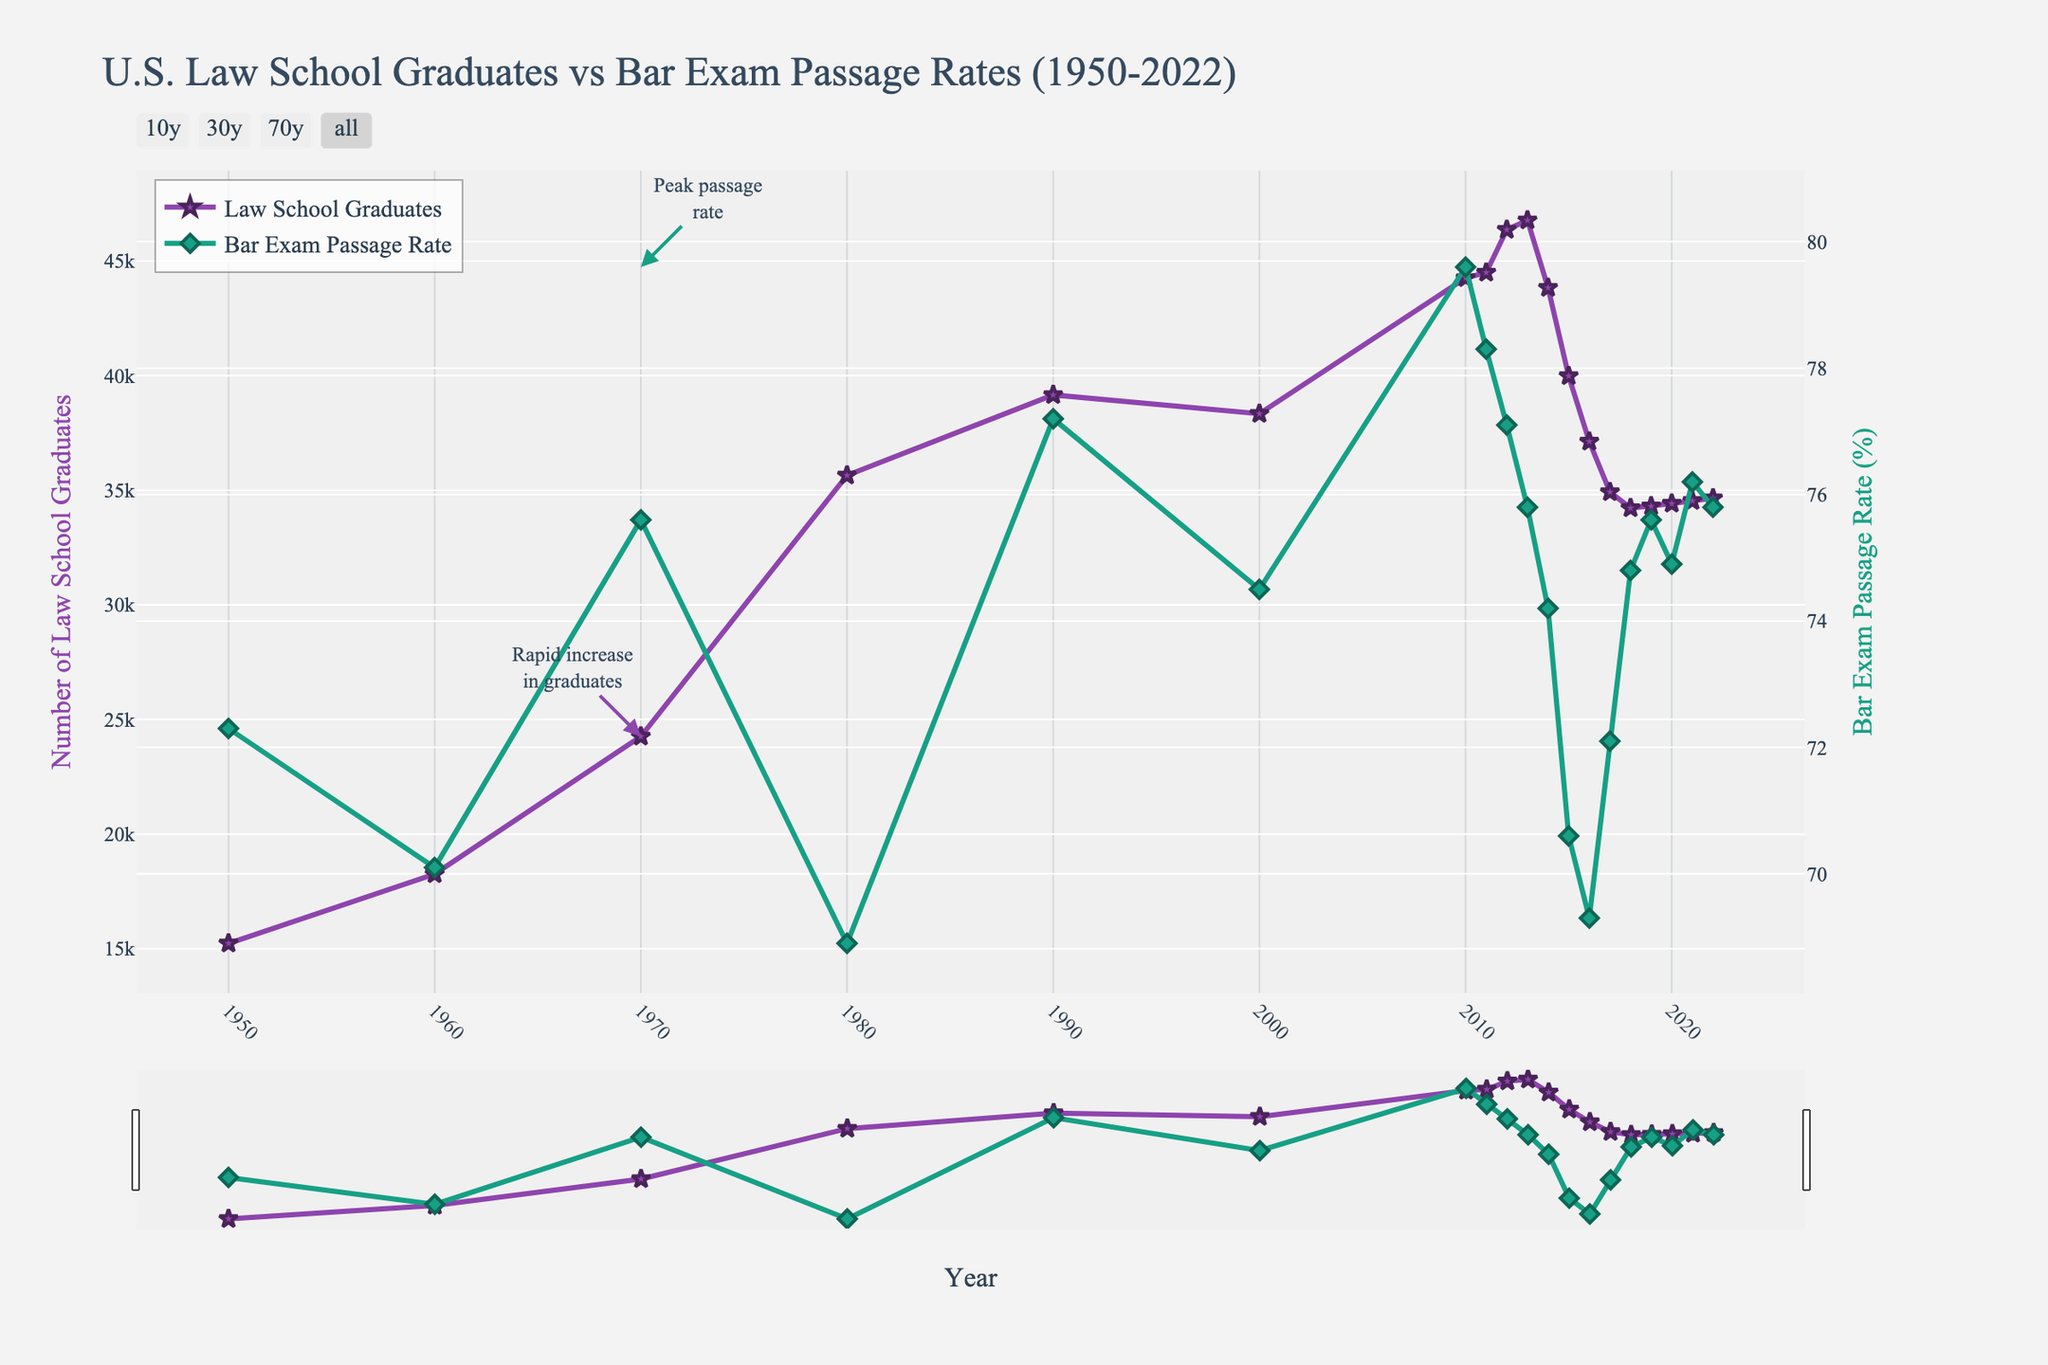What is the general trend of law school graduates from 1950 to 2022? From 1950 to 2022, the number of law school graduates generally increased, particularly from 1950 to 2010. There were fluctuations, with significant rises in the '70s and '80s and a peak around 2010, followed by a slight decrease and stabilization after 2015.
Answer: Gradual increase with fluctuations How did the bar exam passage rate change from 1950 to 2022? The bar exam passage rate fluctuated over time. It started at around 72.3% in 1950, dipped in the 1980s, peaked around 2010 at 79.6%, and then saw a general decrease, with a minor recovery post-2015. It ended at 75.8% in 2022.
Answer: Fluctuated with a peak in 2010 In which year did the number of law school graduates peak, and what was the number? The peak occurred in 2013 when the number of law school graduates was 46,776.
Answer: 2013, 46,776 graduates Is there a year where both the law school graduates and bar exam passage rates show a notable increase? From 2010 to 2011, both the number of law school graduates increased slightly from 44,258 to 44,495 and the bar exam passage rate maintained a relatively high value, despite a slight dip from 79.6% to 78.3%.
Answer: 2010-2011 Which year had the lowest bar exam passage rate, and what was it? The lowest bar exam passage rate occurred in 1980, with a rate of 68.9%.
Answer: 1980, 68.9% Comparing 2000 to 2010, how did the number of law school graduates and bar exam passage rates change? From 2000 to 2010, the number of law school graduates increased from 38,337 to 44,258, and the bar exam passage rate increased from 74.5% to 79.6%.
Answer: Both increased By how much did the number of law school graduates decrease from its peak in 2013 to the lowest point post-2013? The number of law school graduates decreased from 46,776 in 2013 to 34,221 in 2018. The difference is 46,776 - 34,221 = 12,555.
Answer: 12,555 What can be inferred about the relationship between the number of law school graduates and the bar exam passage rate from 1970 to 1980? From 1970 to 1980, the number of law school graduates increased from 24,258 to 35,647. During the same period, the bar exam passage rate decreased from 75.6% to 68.9%. An increase in graduates seems to coincide with a decrease in passage rates.
Answer: Inversely related Between 1960 and 1970, which experienced a larger percent change, the number of law school graduates or the bar exam passage rate? The number of law school graduates increased from 18,258 to 24,258 (33%), while the bar exam passage rate increased from 70.1% to 75.6% (7.9%).
Answer: Law school graduates How did the number of law school graduates in 2022 compare to the number in 1950? In 2022, there were 34,653 law school graduates compared to 15,234 in 1950, showing an increase of 19,419 graduates over the period.
Answer: Increased by 19,419 